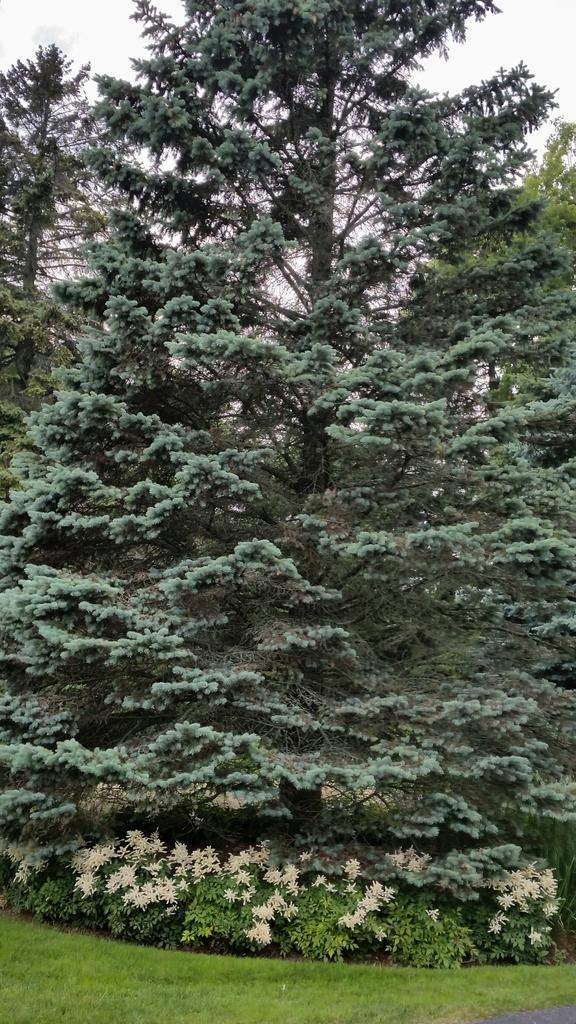What type of vegetation can be seen in the image? There are trees, plants, and grass visible in the image. Are there any flowers present in the image? Yes, there are white flowers in the image. What part of the natural environment is visible in the image? The sky is visible in the image. What type of wine is being served in the image? There is no wine present in the image; it features trees, plants, flowers, grass, and the sky. 